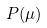<formula> <loc_0><loc_0><loc_500><loc_500>P ( \mu )</formula> 